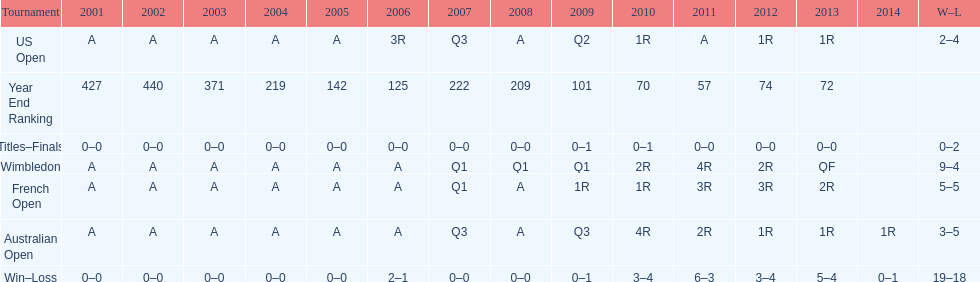In which years were there only 1 loss? 2006, 2009, 2014. 